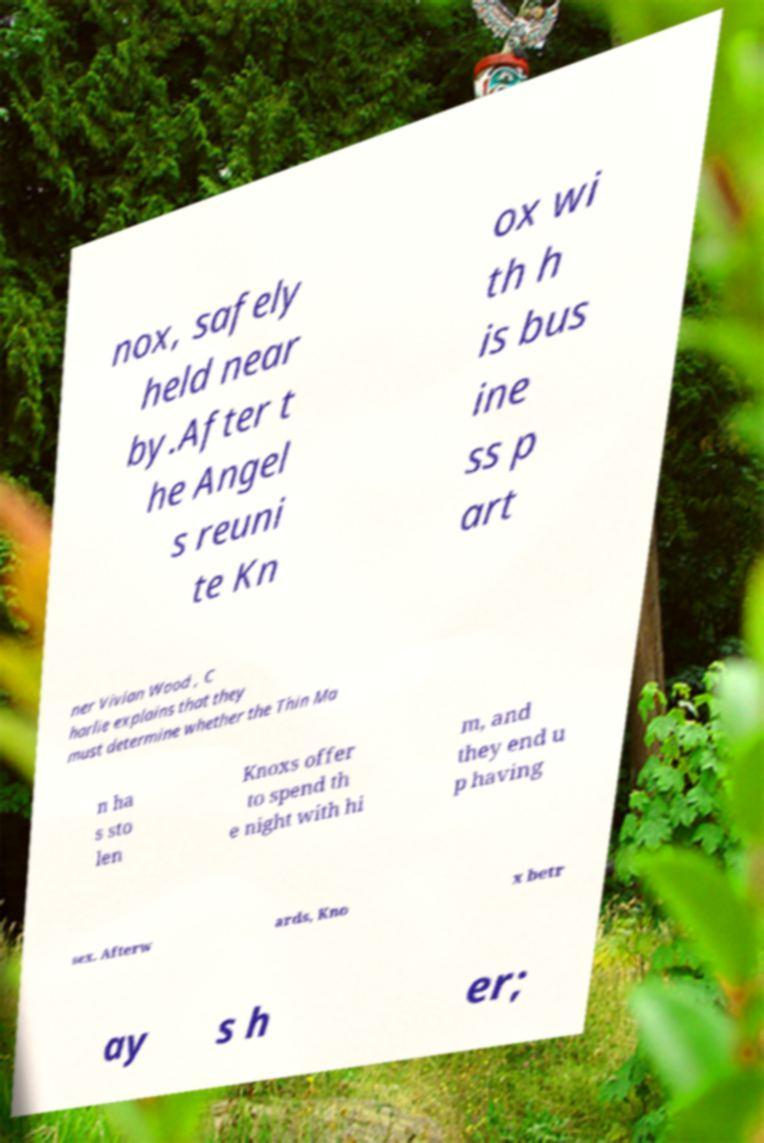I need the written content from this picture converted into text. Can you do that? nox, safely held near by.After t he Angel s reuni te Kn ox wi th h is bus ine ss p art ner Vivian Wood , C harlie explains that they must determine whether the Thin Ma n ha s sto len Knoxs offer to spend th e night with hi m, and they end u p having sex. Afterw ards, Kno x betr ay s h er; 